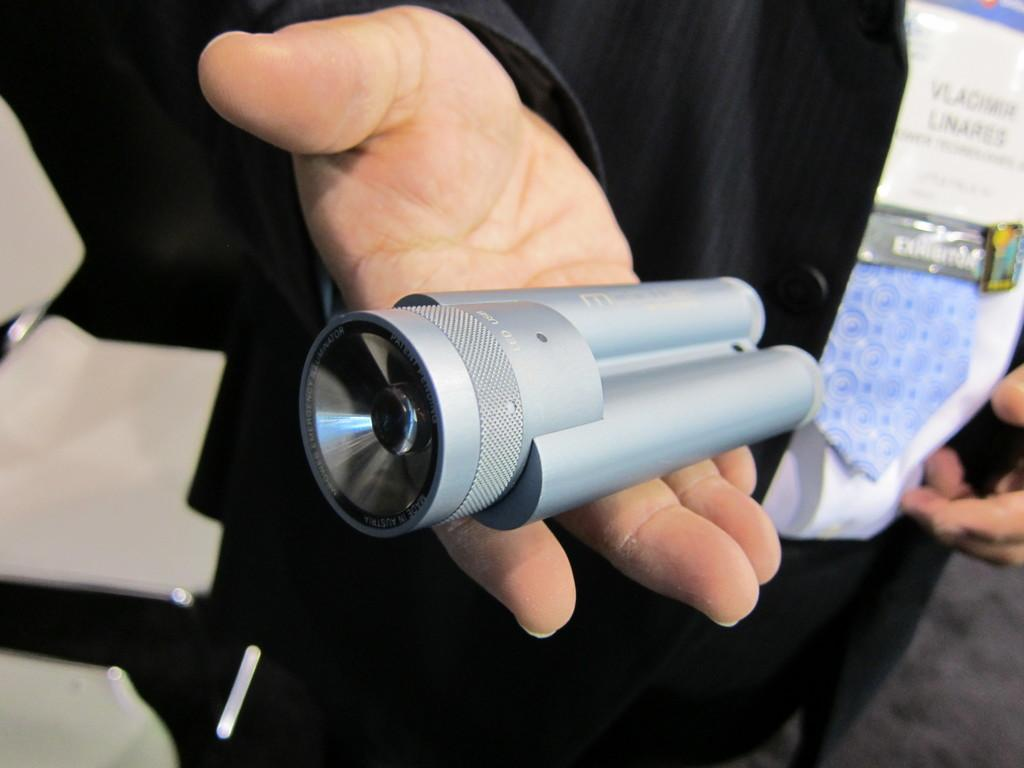Who is present in the image? There is a person in the image. What is the person wearing? The person is wearing a black suit. What object is the person holding? The person is holding a torch light. What is the color of the torch light? The torch light is grey in color. What is the purpose of the drum in the image? There is no drum present in the image. 